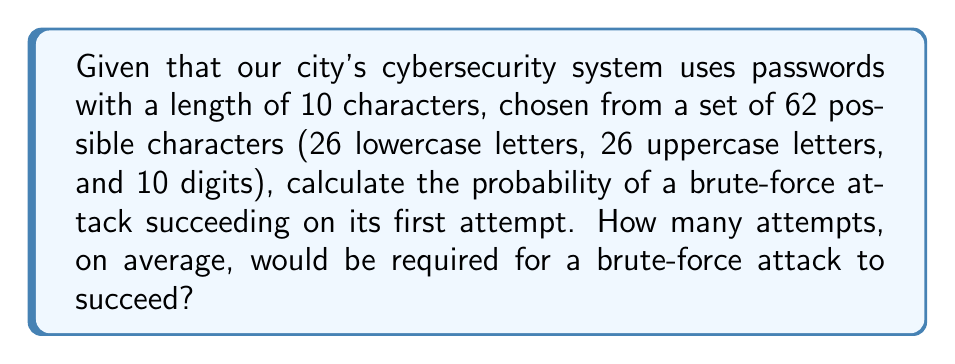Could you help me with this problem? To solve this problem, we need to follow these steps:

1) First, let's calculate the total number of possible passwords:
   - Number of characters in the set: 62
   - Length of the password: 10
   - Total possible passwords: $62^{10}$

2) The probability of guessing the correct password on the first attempt is:
   
   $P(\text{success}) = \frac{1}{\text{total possible passwords}} = \frac{1}{62^{10}}$

3) To calculate the average number of attempts required, we need to use the concept of expected value in probability theory. For a geometric distribution (which this scenario follows), the expected number of trials until success is the reciprocal of the probability of success on a single trial.

   $E(\text{attempts}) = \frac{1}{P(\text{success})} = 62^{10}$

4) Let's calculate this value:
   
   $62^{10} = 839,299,365,868,340,224$

This means that, on average, it would take about 839 quadrillion attempts for a brute-force attack to succeed.
Answer: $P(\text{success}) = \frac{1}{62^{10}}$; Expected attempts $= 62^{10} \approx 8.39 \times 10^{17}$ 